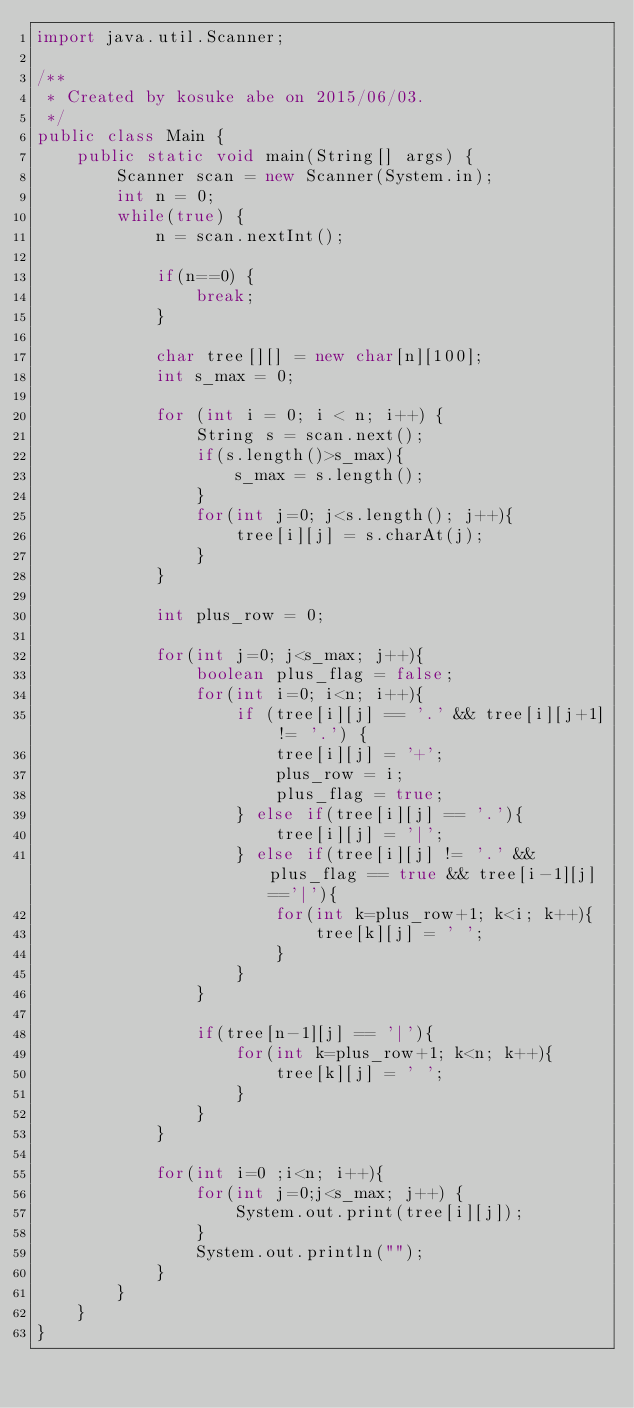<code> <loc_0><loc_0><loc_500><loc_500><_Java_>import java.util.Scanner;

/**
 * Created by kosuke abe on 2015/06/03.
 */
public class Main {
    public static void main(String[] args) {
        Scanner scan = new Scanner(System.in);
        int n = 0;
        while(true) {
            n = scan.nextInt();

            if(n==0) {
                break;
            }

            char tree[][] = new char[n][100];
            int s_max = 0;

            for (int i = 0; i < n; i++) {
                String s = scan.next();
                if(s.length()>s_max){
                    s_max = s.length();
                }
                for(int j=0; j<s.length(); j++){
                    tree[i][j] = s.charAt(j);
                }
            }

            int plus_row = 0;

            for(int j=0; j<s_max; j++){
                boolean plus_flag = false;
                for(int i=0; i<n; i++){
                    if (tree[i][j] == '.' && tree[i][j+1] != '.') {
                        tree[i][j] = '+';
                        plus_row = i;
                        plus_flag = true;
                    } else if(tree[i][j] == '.'){
                        tree[i][j] = '|';
                    } else if(tree[i][j] != '.' && plus_flag == true && tree[i-1][j] =='|'){
                        for(int k=plus_row+1; k<i; k++){
                            tree[k][j] = ' ';
                        }
                    }
                }

                if(tree[n-1][j] == '|'){
                    for(int k=plus_row+1; k<n; k++){
                        tree[k][j] = ' ';
                    }
                }
            }

            for(int i=0 ;i<n; i++){
                for(int j=0;j<s_max; j++) {
                    System.out.print(tree[i][j]);
                }
                System.out.println("");
            }
        }
    }
}</code> 